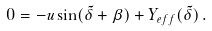<formula> <loc_0><loc_0><loc_500><loc_500>0 = - u \sin ( { \tilde { \delta } } + \beta ) + Y _ { e f f } ( { \tilde { \delta } } ) \, .</formula> 